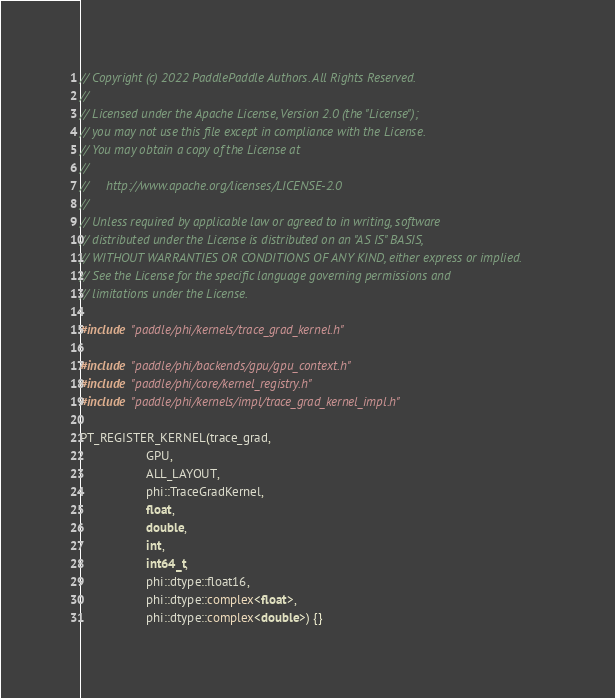Convert code to text. <code><loc_0><loc_0><loc_500><loc_500><_Cuda_>// Copyright (c) 2022 PaddlePaddle Authors. All Rights Reserved.
//
// Licensed under the Apache License, Version 2.0 (the "License");
// you may not use this file except in compliance with the License.
// You may obtain a copy of the License at
//
//     http://www.apache.org/licenses/LICENSE-2.0
//
// Unless required by applicable law or agreed to in writing, software
// distributed under the License is distributed on an "AS IS" BASIS,
// WITHOUT WARRANTIES OR CONDITIONS OF ANY KIND, either express or implied.
// See the License for the specific language governing permissions and
// limitations under the License.

#include "paddle/phi/kernels/trace_grad_kernel.h"

#include "paddle/phi/backends/gpu/gpu_context.h"
#include "paddle/phi/core/kernel_registry.h"
#include "paddle/phi/kernels/impl/trace_grad_kernel_impl.h"

PT_REGISTER_KERNEL(trace_grad,
                   GPU,
                   ALL_LAYOUT,
                   phi::TraceGradKernel,
                   float,
                   double,
                   int,
                   int64_t,
                   phi::dtype::float16,
                   phi::dtype::complex<float>,
                   phi::dtype::complex<double>) {}
</code> 